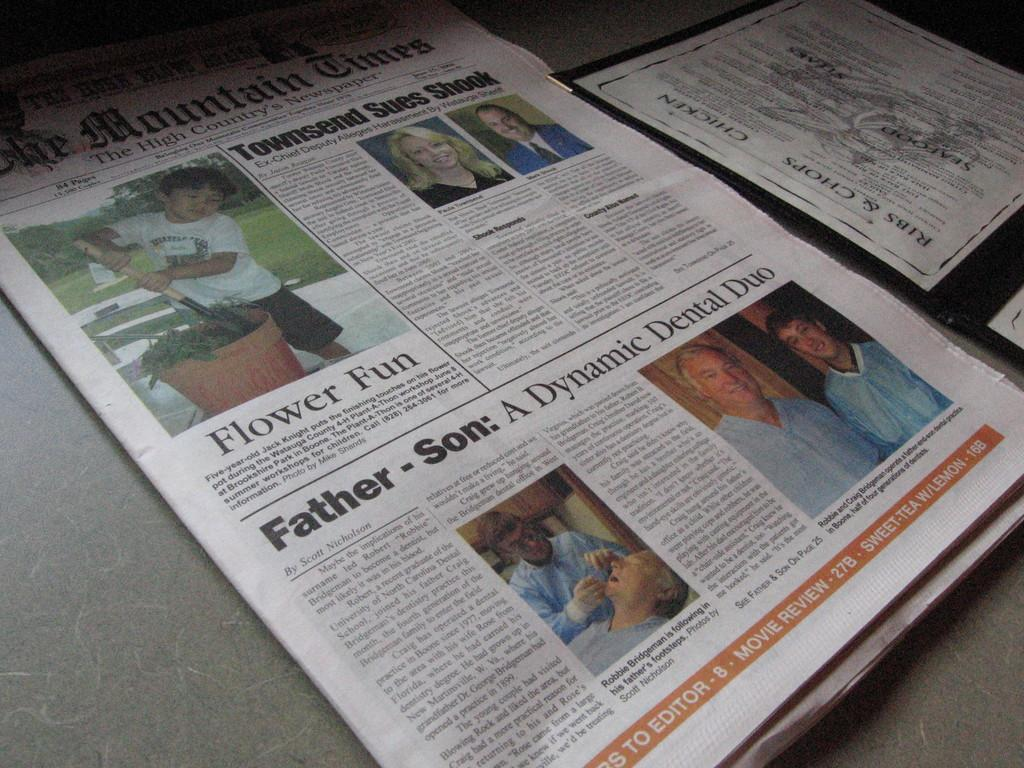Provide a one-sentence caption for the provided image. A newspaper, :The MountainTimes, sits next to a menu on a table. 